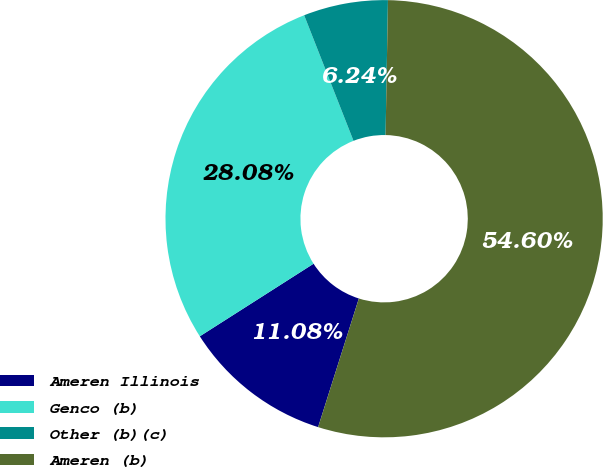Convert chart. <chart><loc_0><loc_0><loc_500><loc_500><pie_chart><fcel>Ameren Illinois<fcel>Genco (b)<fcel>Other (b)(c)<fcel>Ameren (b)<nl><fcel>11.08%<fcel>28.08%<fcel>6.24%<fcel>54.6%<nl></chart> 